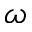<formula> <loc_0><loc_0><loc_500><loc_500>\omega</formula> 